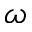<formula> <loc_0><loc_0><loc_500><loc_500>\omega</formula> 